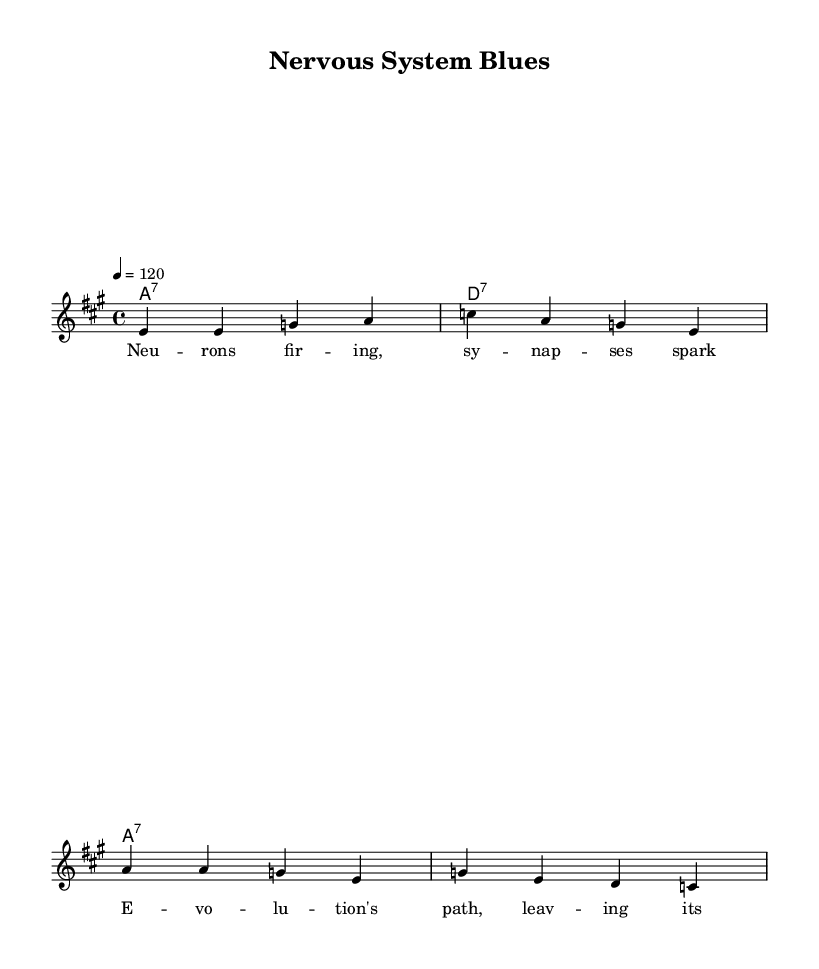What is the key signature of this music? The key signature is A major, which has three sharps: F#, C#, and G#.
Answer: A major What is the time signature of this music? The time signature is 4/4, indicating there are four beats in each measure.
Answer: 4/4 What is the tempo marking of this music? The tempo marking indicates a speed of 120 beats per minute.
Answer: 120 What type of chords are predominantly used in this piece? The predominant chord type is seventh chords, as indicated by the chord names (A7, D7).
Answer: seventh chords What is the theme of the lyrics in this track? The lyrics focus on scientific discovery, evolution, and the nervous system.
Answer: scientific discovery How many measures are there in the melody section? There are four measures in the melody section, corresponding to the provided musical phrases.
Answer: four measures What musical form is reflected in the structure of this piece? The piece may reflect a standard verse form commonly found in electric blues music, where lyrics are set to a repeating musical structure.
Answer: verse form 